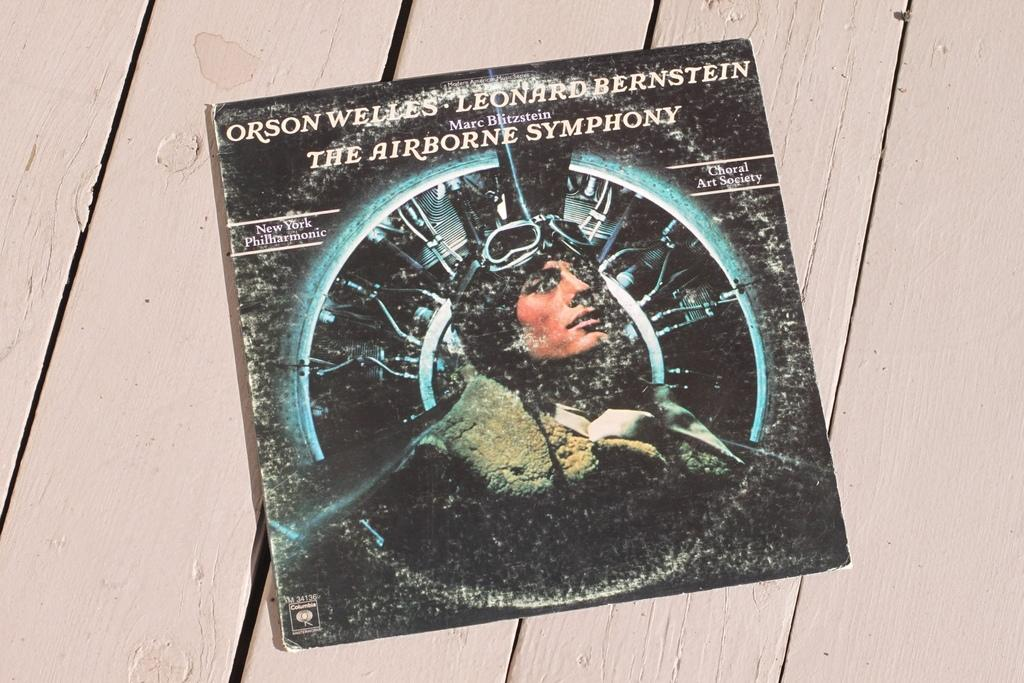What is placed on the wooden surface in the image? There is a board on the wooden surface. What is on the board? There is a person on the board. What type of car can be seen on the board in the image? There is no car present on the board in the image. How many dimes are visible on the board in the image? There are no dimes visible on the board in the image. 